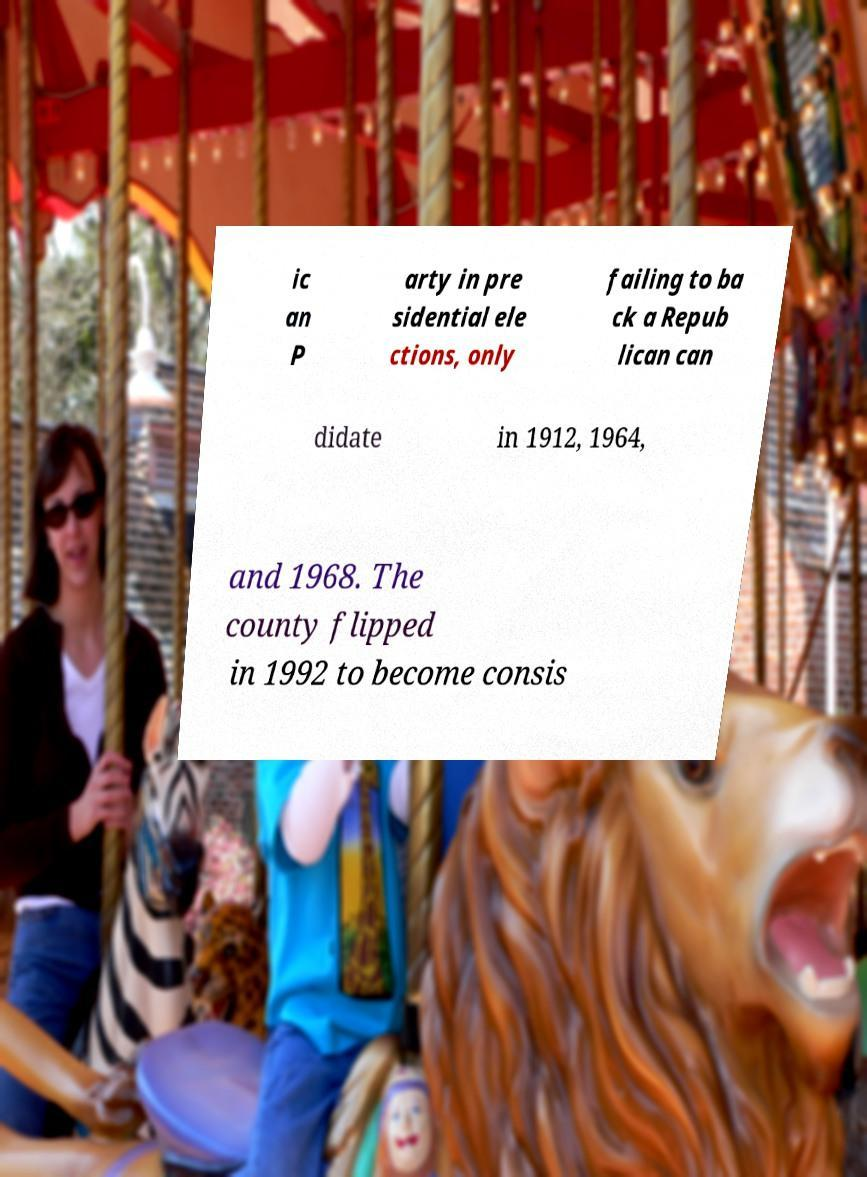Can you accurately transcribe the text from the provided image for me? ic an P arty in pre sidential ele ctions, only failing to ba ck a Repub lican can didate in 1912, 1964, and 1968. The county flipped in 1992 to become consis 